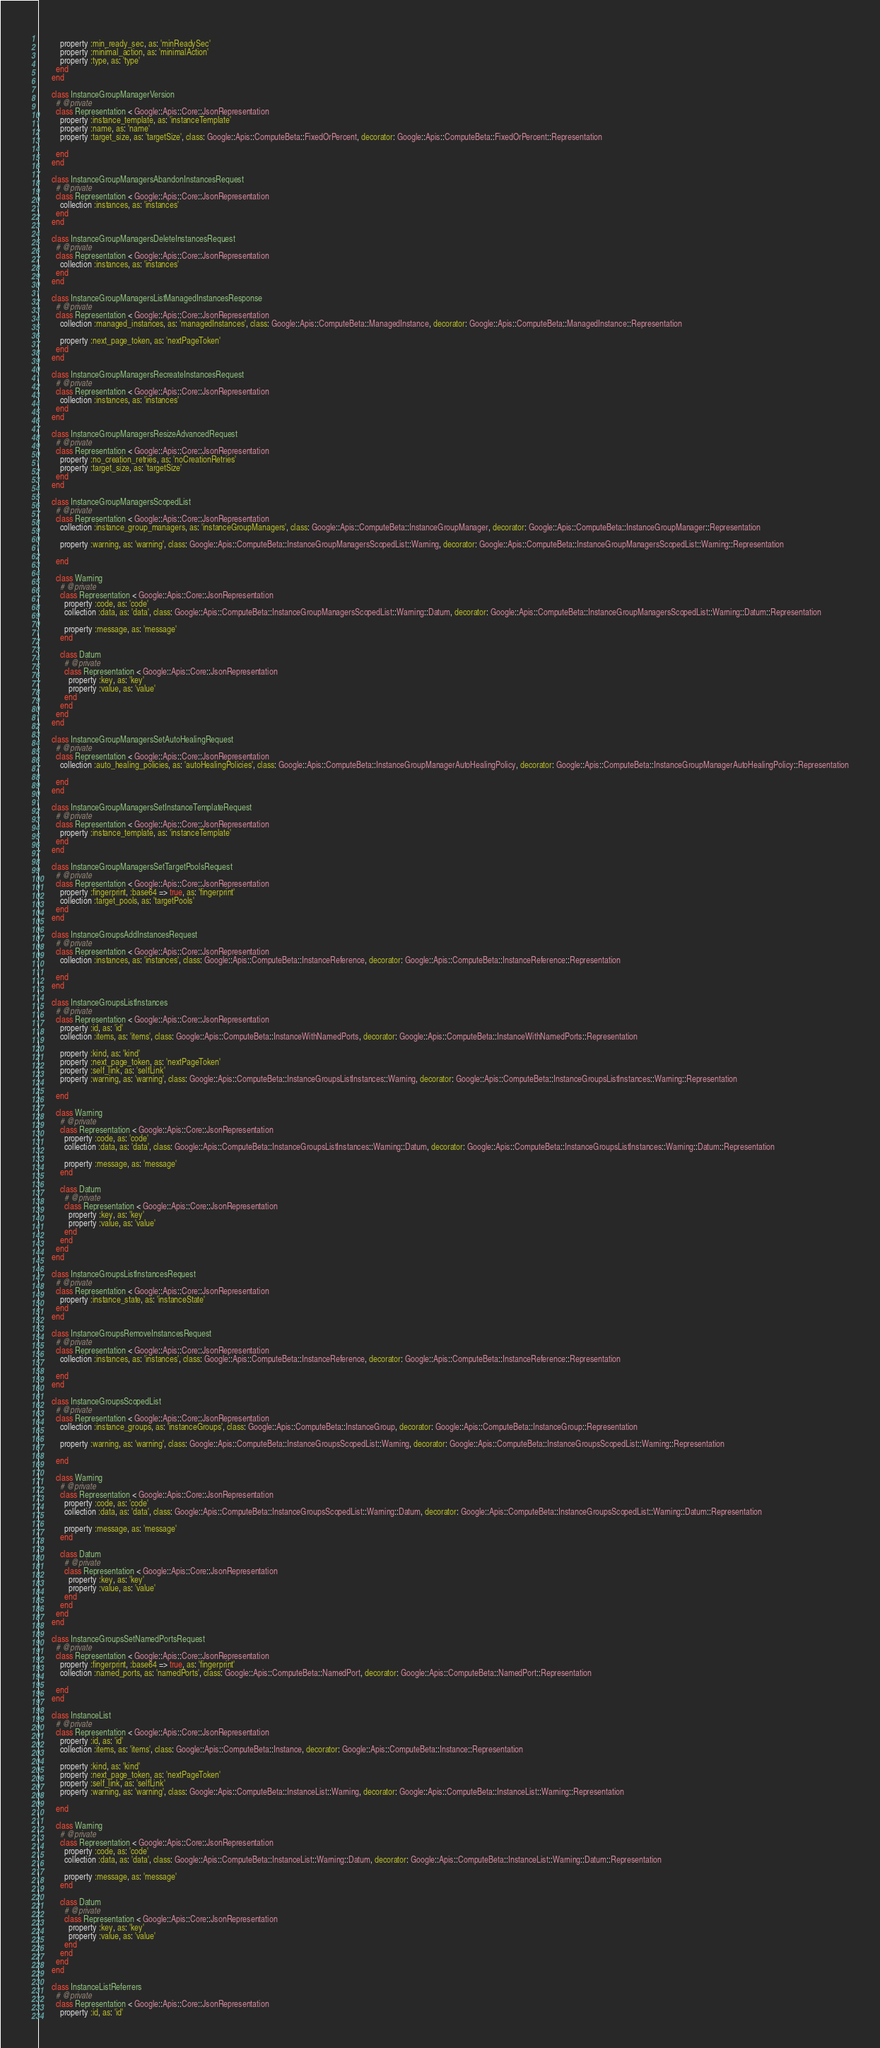<code> <loc_0><loc_0><loc_500><loc_500><_Ruby_>      
          property :min_ready_sec, as: 'minReadySec'
          property :minimal_action, as: 'minimalAction'
          property :type, as: 'type'
        end
      end
      
      class InstanceGroupManagerVersion
        # @private
        class Representation < Google::Apis::Core::JsonRepresentation
          property :instance_template, as: 'instanceTemplate'
          property :name, as: 'name'
          property :target_size, as: 'targetSize', class: Google::Apis::ComputeBeta::FixedOrPercent, decorator: Google::Apis::ComputeBeta::FixedOrPercent::Representation
      
        end
      end
      
      class InstanceGroupManagersAbandonInstancesRequest
        # @private
        class Representation < Google::Apis::Core::JsonRepresentation
          collection :instances, as: 'instances'
        end
      end
      
      class InstanceGroupManagersDeleteInstancesRequest
        # @private
        class Representation < Google::Apis::Core::JsonRepresentation
          collection :instances, as: 'instances'
        end
      end
      
      class InstanceGroupManagersListManagedInstancesResponse
        # @private
        class Representation < Google::Apis::Core::JsonRepresentation
          collection :managed_instances, as: 'managedInstances', class: Google::Apis::ComputeBeta::ManagedInstance, decorator: Google::Apis::ComputeBeta::ManagedInstance::Representation
      
          property :next_page_token, as: 'nextPageToken'
        end
      end
      
      class InstanceGroupManagersRecreateInstancesRequest
        # @private
        class Representation < Google::Apis::Core::JsonRepresentation
          collection :instances, as: 'instances'
        end
      end
      
      class InstanceGroupManagersResizeAdvancedRequest
        # @private
        class Representation < Google::Apis::Core::JsonRepresentation
          property :no_creation_retries, as: 'noCreationRetries'
          property :target_size, as: 'targetSize'
        end
      end
      
      class InstanceGroupManagersScopedList
        # @private
        class Representation < Google::Apis::Core::JsonRepresentation
          collection :instance_group_managers, as: 'instanceGroupManagers', class: Google::Apis::ComputeBeta::InstanceGroupManager, decorator: Google::Apis::ComputeBeta::InstanceGroupManager::Representation
      
          property :warning, as: 'warning', class: Google::Apis::ComputeBeta::InstanceGroupManagersScopedList::Warning, decorator: Google::Apis::ComputeBeta::InstanceGroupManagersScopedList::Warning::Representation
      
        end
        
        class Warning
          # @private
          class Representation < Google::Apis::Core::JsonRepresentation
            property :code, as: 'code'
            collection :data, as: 'data', class: Google::Apis::ComputeBeta::InstanceGroupManagersScopedList::Warning::Datum, decorator: Google::Apis::ComputeBeta::InstanceGroupManagersScopedList::Warning::Datum::Representation
        
            property :message, as: 'message'
          end
          
          class Datum
            # @private
            class Representation < Google::Apis::Core::JsonRepresentation
              property :key, as: 'key'
              property :value, as: 'value'
            end
          end
        end
      end
      
      class InstanceGroupManagersSetAutoHealingRequest
        # @private
        class Representation < Google::Apis::Core::JsonRepresentation
          collection :auto_healing_policies, as: 'autoHealingPolicies', class: Google::Apis::ComputeBeta::InstanceGroupManagerAutoHealingPolicy, decorator: Google::Apis::ComputeBeta::InstanceGroupManagerAutoHealingPolicy::Representation
      
        end
      end
      
      class InstanceGroupManagersSetInstanceTemplateRequest
        # @private
        class Representation < Google::Apis::Core::JsonRepresentation
          property :instance_template, as: 'instanceTemplate'
        end
      end
      
      class InstanceGroupManagersSetTargetPoolsRequest
        # @private
        class Representation < Google::Apis::Core::JsonRepresentation
          property :fingerprint, :base64 => true, as: 'fingerprint'
          collection :target_pools, as: 'targetPools'
        end
      end
      
      class InstanceGroupsAddInstancesRequest
        # @private
        class Representation < Google::Apis::Core::JsonRepresentation
          collection :instances, as: 'instances', class: Google::Apis::ComputeBeta::InstanceReference, decorator: Google::Apis::ComputeBeta::InstanceReference::Representation
      
        end
      end
      
      class InstanceGroupsListInstances
        # @private
        class Representation < Google::Apis::Core::JsonRepresentation
          property :id, as: 'id'
          collection :items, as: 'items', class: Google::Apis::ComputeBeta::InstanceWithNamedPorts, decorator: Google::Apis::ComputeBeta::InstanceWithNamedPorts::Representation
      
          property :kind, as: 'kind'
          property :next_page_token, as: 'nextPageToken'
          property :self_link, as: 'selfLink'
          property :warning, as: 'warning', class: Google::Apis::ComputeBeta::InstanceGroupsListInstances::Warning, decorator: Google::Apis::ComputeBeta::InstanceGroupsListInstances::Warning::Representation
      
        end
        
        class Warning
          # @private
          class Representation < Google::Apis::Core::JsonRepresentation
            property :code, as: 'code'
            collection :data, as: 'data', class: Google::Apis::ComputeBeta::InstanceGroupsListInstances::Warning::Datum, decorator: Google::Apis::ComputeBeta::InstanceGroupsListInstances::Warning::Datum::Representation
        
            property :message, as: 'message'
          end
          
          class Datum
            # @private
            class Representation < Google::Apis::Core::JsonRepresentation
              property :key, as: 'key'
              property :value, as: 'value'
            end
          end
        end
      end
      
      class InstanceGroupsListInstancesRequest
        # @private
        class Representation < Google::Apis::Core::JsonRepresentation
          property :instance_state, as: 'instanceState'
        end
      end
      
      class InstanceGroupsRemoveInstancesRequest
        # @private
        class Representation < Google::Apis::Core::JsonRepresentation
          collection :instances, as: 'instances', class: Google::Apis::ComputeBeta::InstanceReference, decorator: Google::Apis::ComputeBeta::InstanceReference::Representation
      
        end
      end
      
      class InstanceGroupsScopedList
        # @private
        class Representation < Google::Apis::Core::JsonRepresentation
          collection :instance_groups, as: 'instanceGroups', class: Google::Apis::ComputeBeta::InstanceGroup, decorator: Google::Apis::ComputeBeta::InstanceGroup::Representation
      
          property :warning, as: 'warning', class: Google::Apis::ComputeBeta::InstanceGroupsScopedList::Warning, decorator: Google::Apis::ComputeBeta::InstanceGroupsScopedList::Warning::Representation
      
        end
        
        class Warning
          # @private
          class Representation < Google::Apis::Core::JsonRepresentation
            property :code, as: 'code'
            collection :data, as: 'data', class: Google::Apis::ComputeBeta::InstanceGroupsScopedList::Warning::Datum, decorator: Google::Apis::ComputeBeta::InstanceGroupsScopedList::Warning::Datum::Representation
        
            property :message, as: 'message'
          end
          
          class Datum
            # @private
            class Representation < Google::Apis::Core::JsonRepresentation
              property :key, as: 'key'
              property :value, as: 'value'
            end
          end
        end
      end
      
      class InstanceGroupsSetNamedPortsRequest
        # @private
        class Representation < Google::Apis::Core::JsonRepresentation
          property :fingerprint, :base64 => true, as: 'fingerprint'
          collection :named_ports, as: 'namedPorts', class: Google::Apis::ComputeBeta::NamedPort, decorator: Google::Apis::ComputeBeta::NamedPort::Representation
      
        end
      end
      
      class InstanceList
        # @private
        class Representation < Google::Apis::Core::JsonRepresentation
          property :id, as: 'id'
          collection :items, as: 'items', class: Google::Apis::ComputeBeta::Instance, decorator: Google::Apis::ComputeBeta::Instance::Representation
      
          property :kind, as: 'kind'
          property :next_page_token, as: 'nextPageToken'
          property :self_link, as: 'selfLink'
          property :warning, as: 'warning', class: Google::Apis::ComputeBeta::InstanceList::Warning, decorator: Google::Apis::ComputeBeta::InstanceList::Warning::Representation
      
        end
        
        class Warning
          # @private
          class Representation < Google::Apis::Core::JsonRepresentation
            property :code, as: 'code'
            collection :data, as: 'data', class: Google::Apis::ComputeBeta::InstanceList::Warning::Datum, decorator: Google::Apis::ComputeBeta::InstanceList::Warning::Datum::Representation
        
            property :message, as: 'message'
          end
          
          class Datum
            # @private
            class Representation < Google::Apis::Core::JsonRepresentation
              property :key, as: 'key'
              property :value, as: 'value'
            end
          end
        end
      end
      
      class InstanceListReferrers
        # @private
        class Representation < Google::Apis::Core::JsonRepresentation
          property :id, as: 'id'</code> 